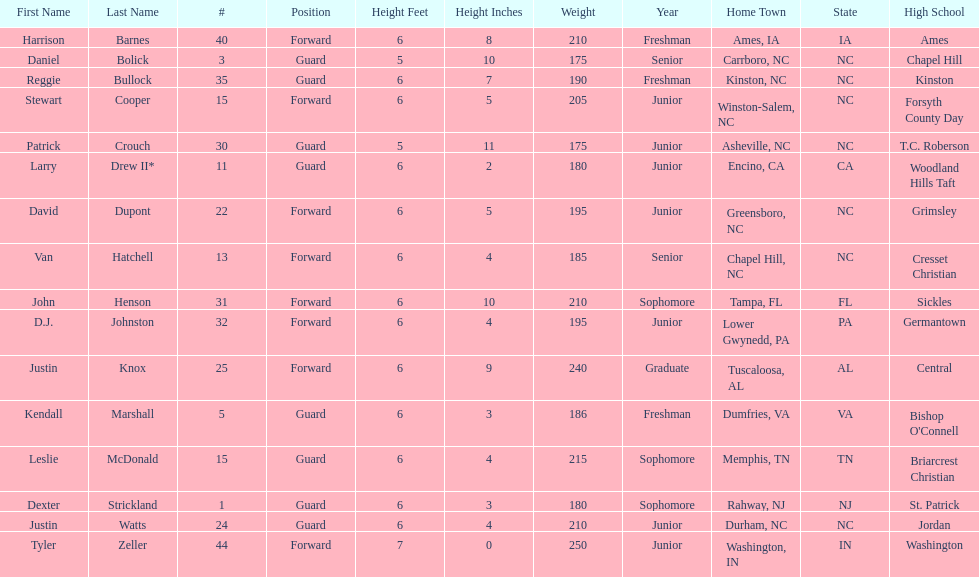Names of players who were exactly 6 feet, 4 inches tall, but did not weight over 200 pounds Van Hatchell, D.J. Johnston. 